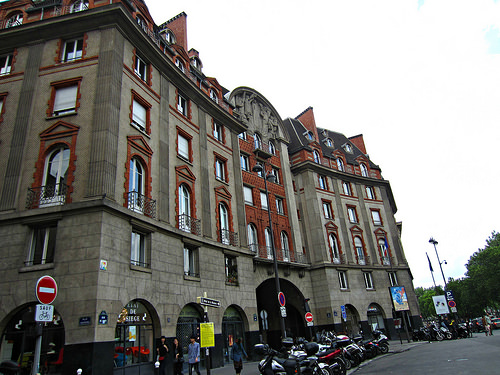<image>
Is the window next to the window? No. The window is not positioned next to the window. They are located in different areas of the scene. 